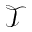Convert formula to latex. <formula><loc_0><loc_0><loc_500><loc_500>\mathcal { T }</formula> 